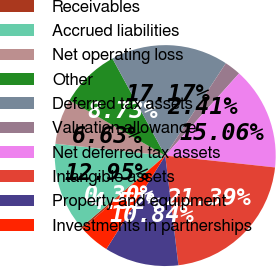Convert chart. <chart><loc_0><loc_0><loc_500><loc_500><pie_chart><fcel>Receivables<fcel>Accrued liabilities<fcel>Net operating loss<fcel>Other<fcel>Deferred tax assets<fcel>Valuation allowance<fcel>Net deferred tax assets<fcel>Intangible assets<fcel>Property and equipment<fcel>Investments in partnerships<nl><fcel>0.3%<fcel>12.95%<fcel>6.63%<fcel>8.73%<fcel>17.17%<fcel>2.41%<fcel>15.06%<fcel>21.39%<fcel>10.84%<fcel>4.52%<nl></chart> 